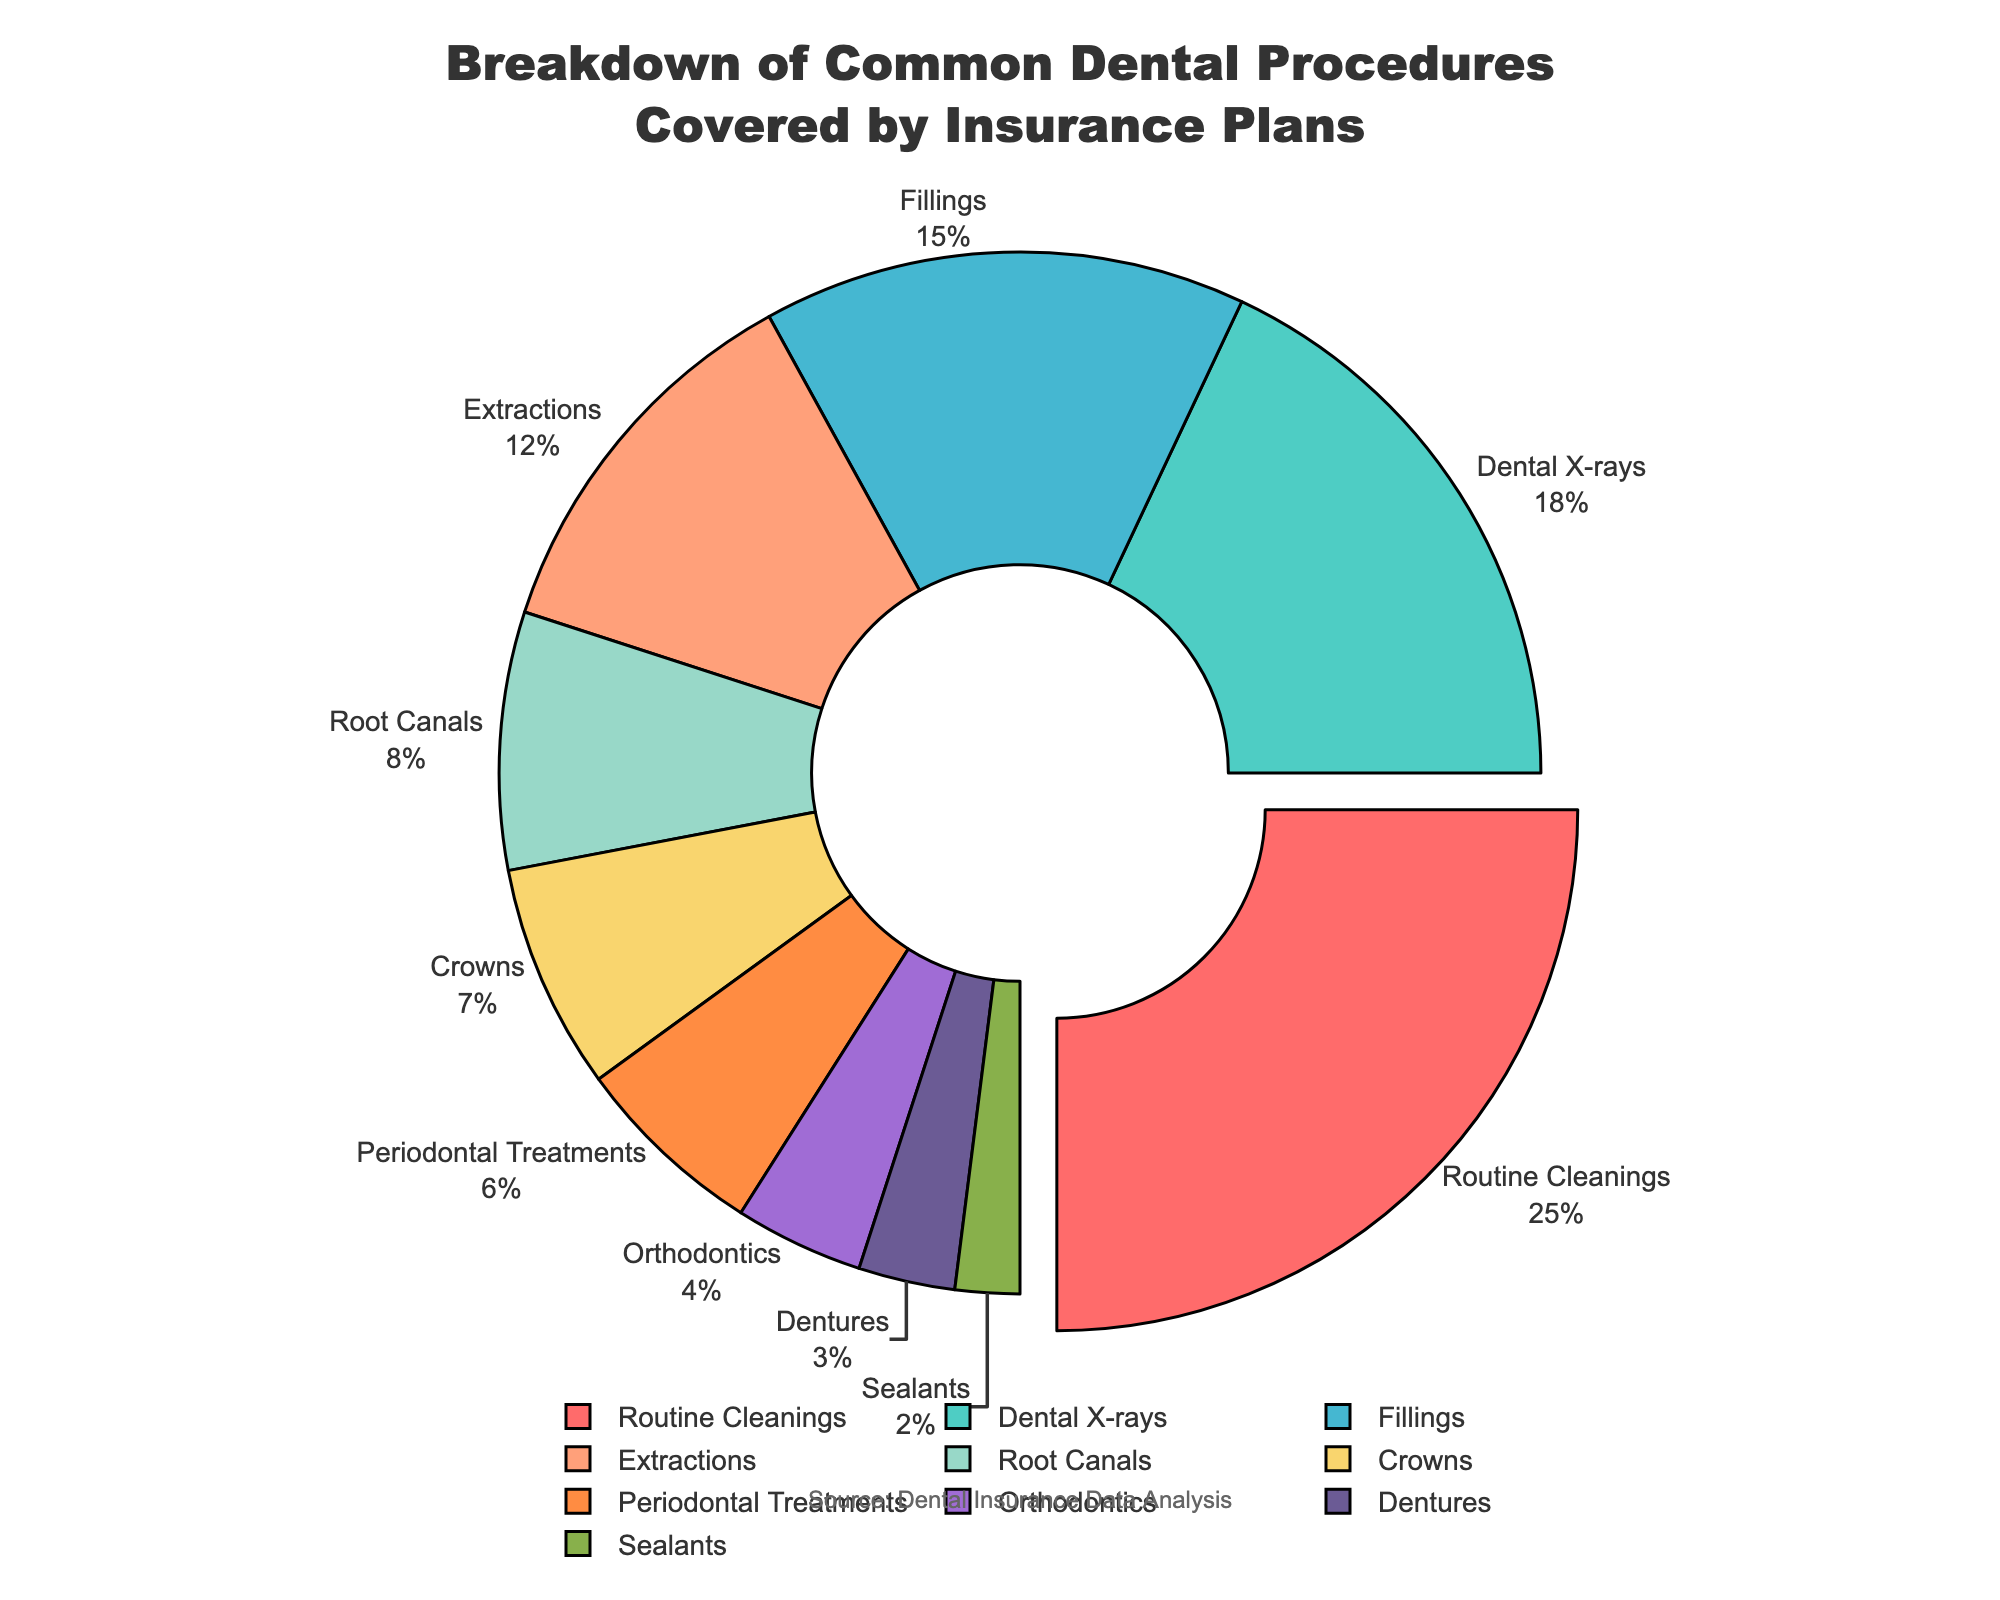What is the most common dental procedure covered by insurance plans? The most common dental procedure is the one with the largest percentage in the pie chart. By looking at the pie chart, Routine Cleanings has the largest slice with 25%.
Answer: Routine Cleanings Which procedure is covered more: Fillings or Root Canals? To determine which procedure is covered more, compare the percentages for Fillings and Root Canals. Fillings cover 15%, while Root Canals cover 8%.
Answer: Fillings What percentage of the covered procedures is for Routine Cleanings and Dental X-rays combined? Add the percentages for Routine Cleanings (25%) and Dental X-rays (18%). The combined percentage is 25% + 18% = 43%.
Answer: 43% How much more common are Routine Cleanings compared to Orthodontics? Subtract the percentage for Orthodontics (4%) from the percentage for Routine Cleanings (25%). The difference is 25% - 4% = 21%.
Answer: 21% Which slice of the pie chart is smallest, and what does it represent? The smallest slice of the pie chart represents the procedure with the smallest percentage. The Sealants slice is the smallest, with 2%.
Answer: Sealants Rank the top three procedures covered by the insurance plans in descending order. Identify the procedures with the three highest percentages. The top three are Routine Cleanings (25%), Dental X-rays (18%), and Fillings (15%).
Answer: Routine Cleanings, Dental X-rays, Fillings What percentage of the procedures are covered by Root Canals and Crowns combined? Add the percentages for Root Canals (8%) and Crowns (7%). The combined percentage is 8% + 7% = 15%.
Answer: 15% What visual characteristics distinguish the slice for the most common procedure? The slice for the most common procedure (Routine Cleanings, 25%) is visually distinguished by being pulled out slightly from the center of the pie chart.
Answer: Pulled out Identify all the procedures that individually cover less than 10 percent. By examining the percentages, the procedures that cover less than 10% are Root Canals (8%), Crowns (7%), Periodontal Treatments (6%), Orthodontics (4%), Dentures (3%), and Sealants (2%).
Answer: Root Canals, Crowns, Periodontal Treatments, Orthodontics, Dentures, Sealants What total percentage of the pie chart do Periodontal Treatments, Orthodontics, and Dentures cover? Sum the percentages for Periodontal Treatments (6%), Orthodontics (4%), and Dentures (3%). The total is 6% + 4% + 3% = 13%.
Answer: 13% 